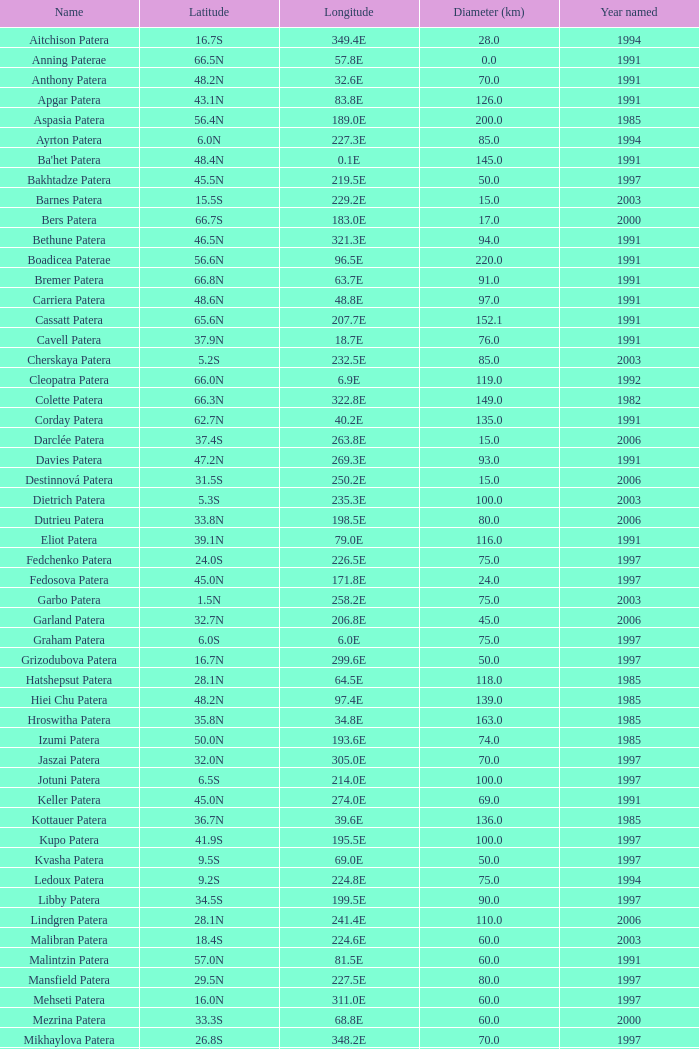9n, and when diameter (km) is over 76? None. 